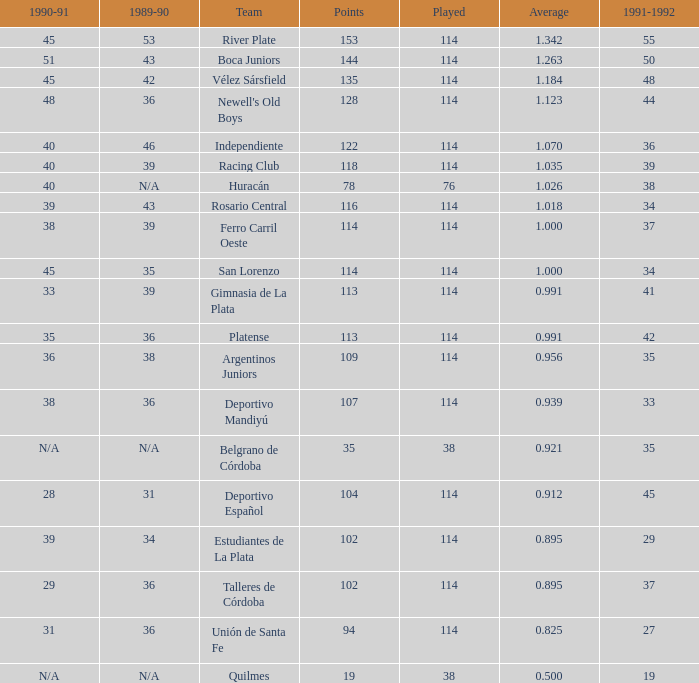How much 1991-1992 has a 1989-90 of 36, and an Average of 0.8250000000000001? 0.0. 